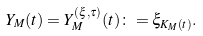<formula> <loc_0><loc_0><loc_500><loc_500>Y _ { M } ( t ) = Y _ { M } ^ { ( \xi , \tau ) } ( t ) \colon = \xi _ { K _ { M } ( t ) } .</formula> 